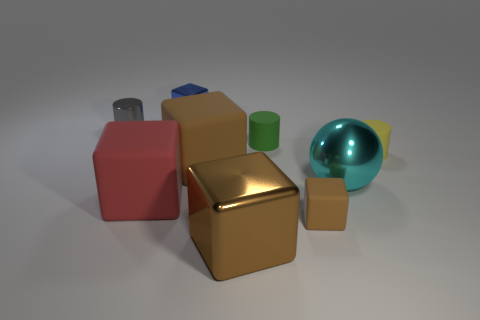What materials do the objects in the image seem to be made from? The objects in this image have a variety of textures that suggest different materials. The golden block looks metallic with a reflective surface, the blue and red blocks seem to have a matte finish resembling plastic, the green cylinder might be rubber due to its less reflective finish, and the teal sphere has a glossy surface that could imply a glass-like or polished stone material. 